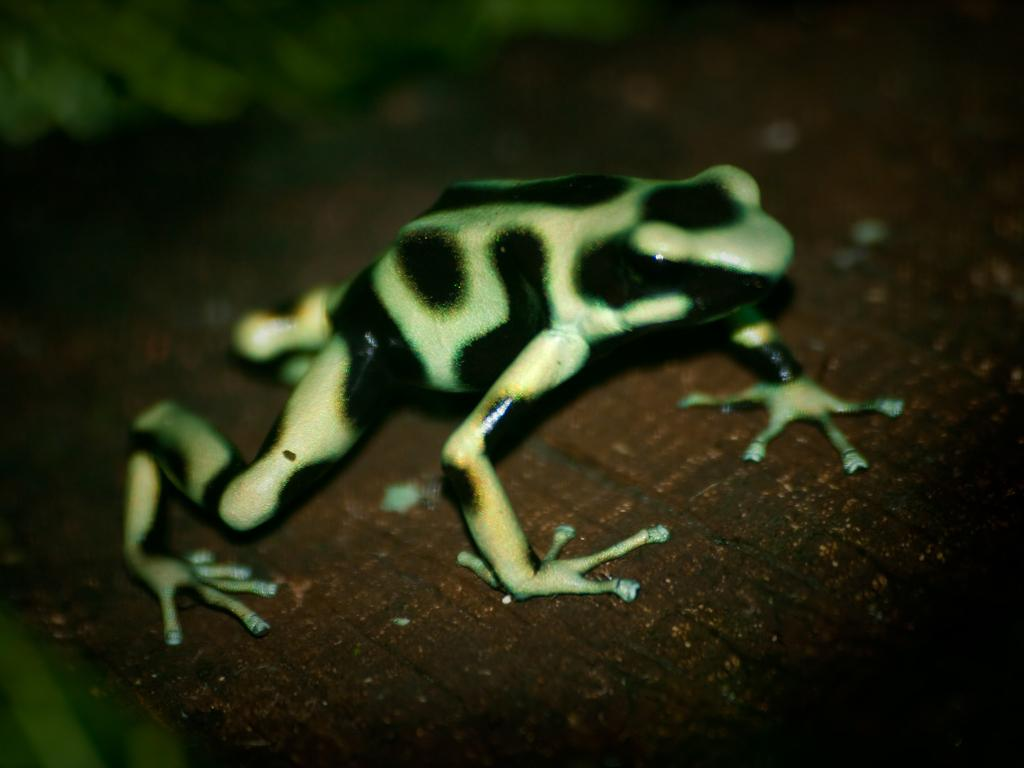What type of animal is present in the image? There is a frog in the image. What type of alarm is the frog using in the image? There is no alarm present in the image, as it features a frog. 